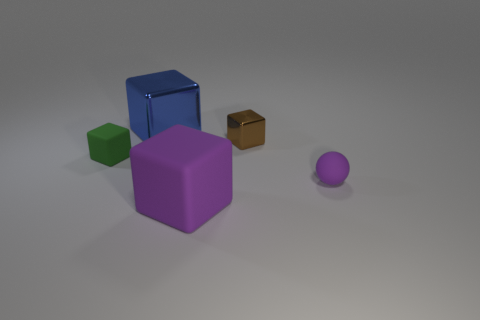Subtract 1 cubes. How many cubes are left? 3 Add 1 large gray cylinders. How many objects exist? 6 Subtract all blocks. How many objects are left? 1 Subtract all large rubber blocks. Subtract all big purple cubes. How many objects are left? 3 Add 3 big matte cubes. How many big matte cubes are left? 4 Add 2 tiny purple shiny objects. How many tiny purple shiny objects exist? 2 Subtract 0 yellow balls. How many objects are left? 5 